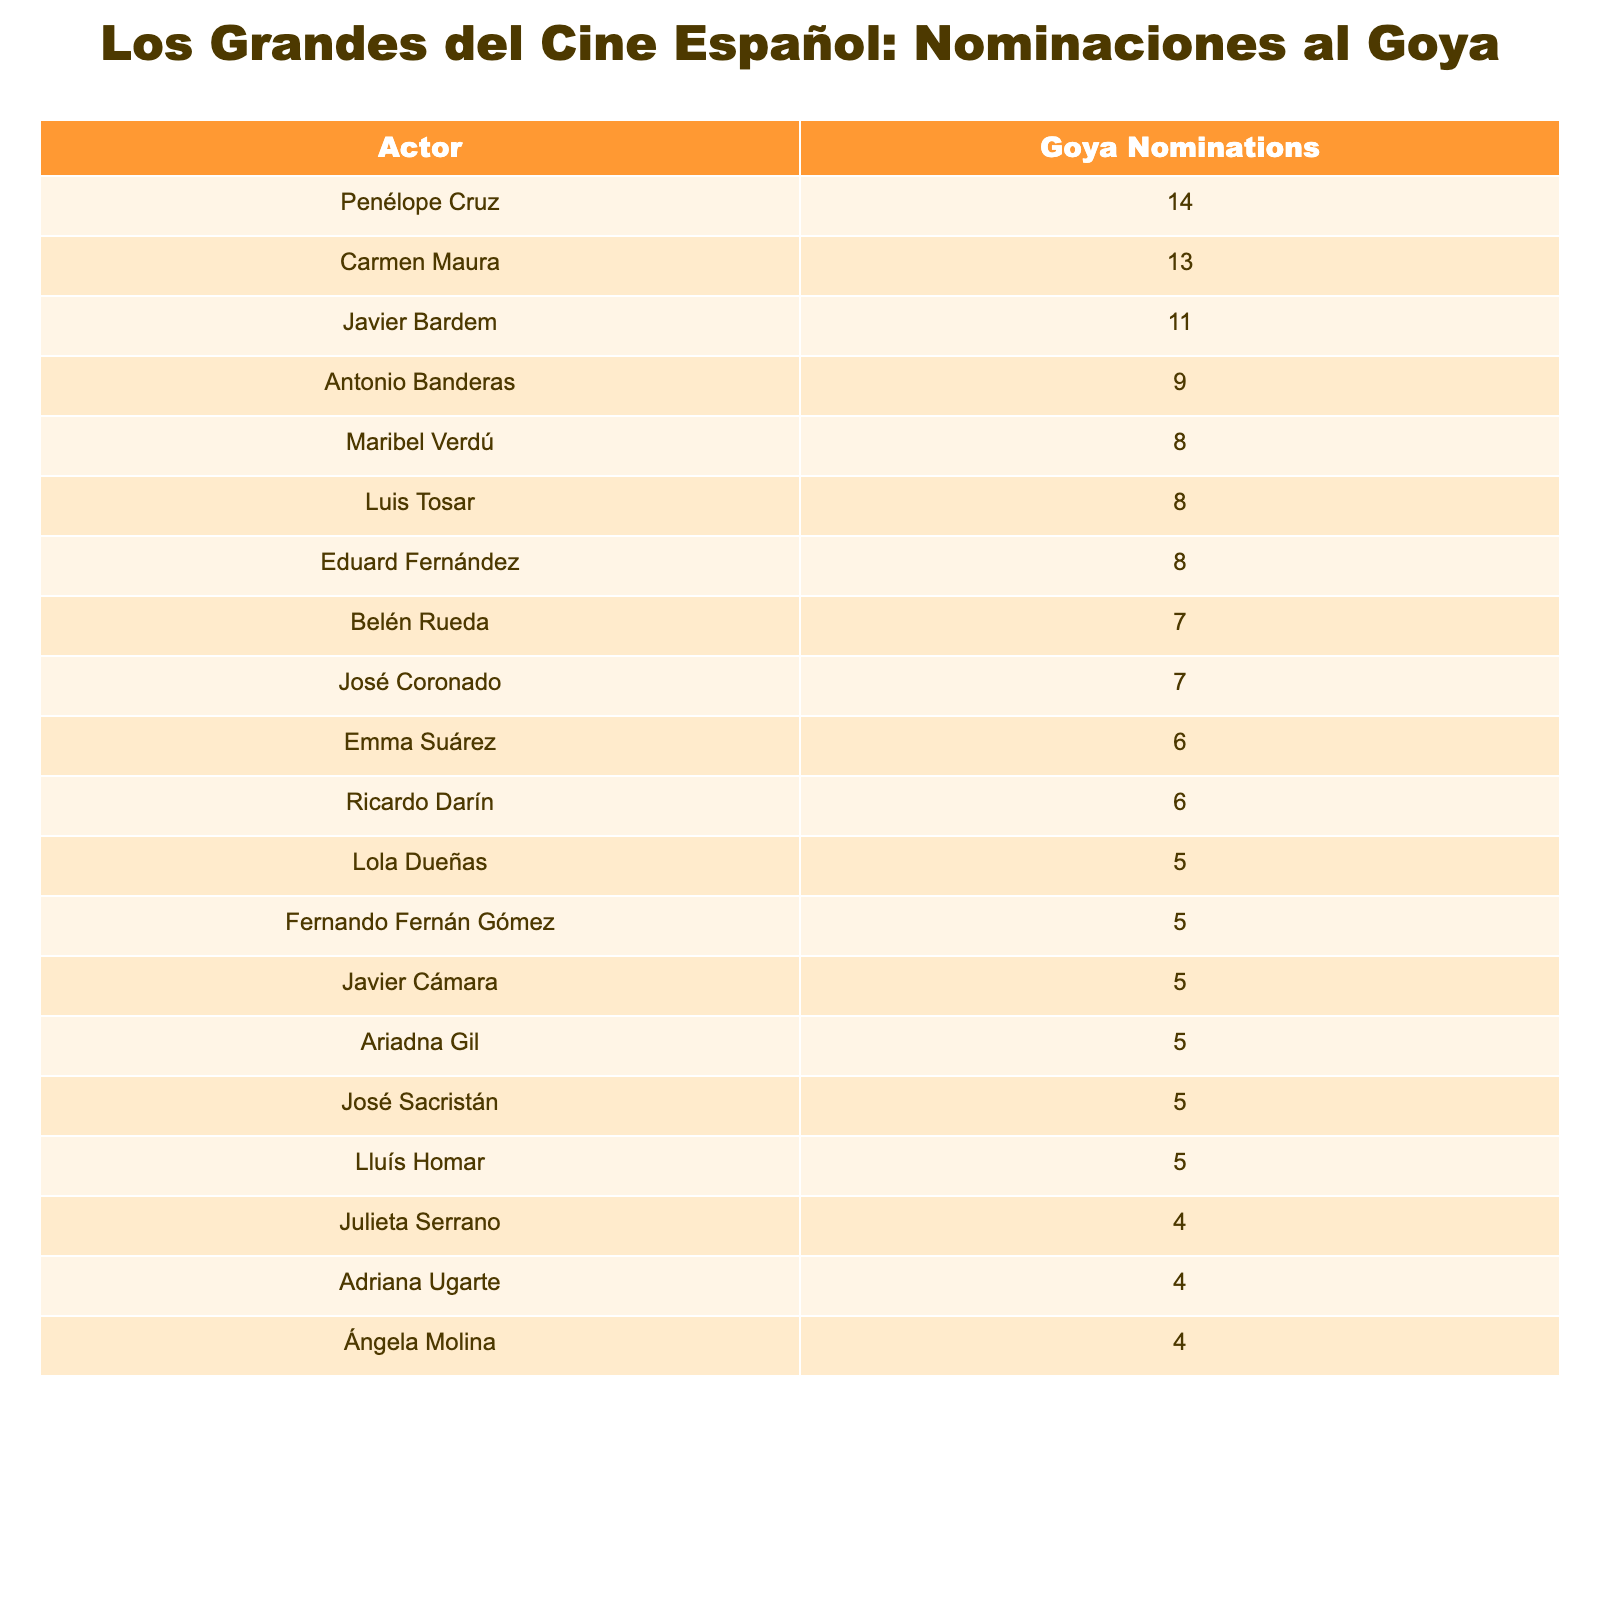What is the actor with the most Goya Award nominations? The table lists Penélope Cruz as having the highest number of nominations at 14.
Answer: Penélope Cruz How many nominations does Carmen Maura have? According to the table, Carmen Maura has 13 Goya nominations.
Answer: 13 Which actor shares the same number of nominations as Maribel Verdú? The table shows that both Luis Tosar and Eduard Fernández also have 8 nominations, matching Maribel Verdú's count.
Answer: Luis Tosar, Eduard Fernández What is the total number of Goya nominations among the top three actors? The top three actors, Penélope Cruz, Carmen Maura, and Javier Bardem have a total of (14 + 13 + 11) = 38 nominations combined.
Answer: 38 Is Antonio Banderas among the top five actors with nominations? Yes, the table indicates Antonio Banderas is in the top five with 9 nominations.
Answer: Yes Who is the least nominated actor listed in the table? The table reveals that Julieta Serrano, Adriana Ugarte, and Ángela Molina each have 4 nominations, which is the lowest among the listed actors.
Answer: Julieta Serrano, Adriana Ugarte, Ángela Molina What is the average number of nominations for all actors listed in the table? To calculate the average, sum all the nominations: (14 + 13 + 11 + 9 + 8 + 8 + 8 + 7 + 7 + 6 + 6 + 5 + 5 + 5 + 5 + 5 + 4 + 4 + 4) =  135. There are 18 actors, therefore the average is 135 / 18 = 7.5.
Answer: 7.5 How many actors have received 6 or more nominations? The table indicates 11 actors have received 6 or more nominations when counting them from Penélope Cruz down to José Sacristán.
Answer: 11 Which two actors are tied for the same number of nominations? The table shows that José Coronado and Belén Rueda are tied with 7 nominations each.
Answer: José Coronado, Belén Rueda What percentage of the total nominations does Penélope Cruz account for? Penélope Cruz has 14 nominations out of a total of 135 nominations. Calculating the percentage: (14 / 135) * 100 = 10.37%.
Answer: 10.37% 